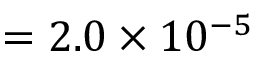Convert formula to latex. <formula><loc_0><loc_0><loc_500><loc_500>= 2 . 0 \times 1 0 ^ { - 5 }</formula> 